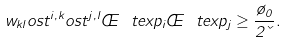Convert formula to latex. <formula><loc_0><loc_0><loc_500><loc_500>w _ { k l } o s t ^ { i , k } o s t ^ { j , l } \phi \ t e x p _ { i } \phi \ t e x p _ { j } \geq \frac { \tau _ { 0 } } { 2 \kappa } .</formula> 